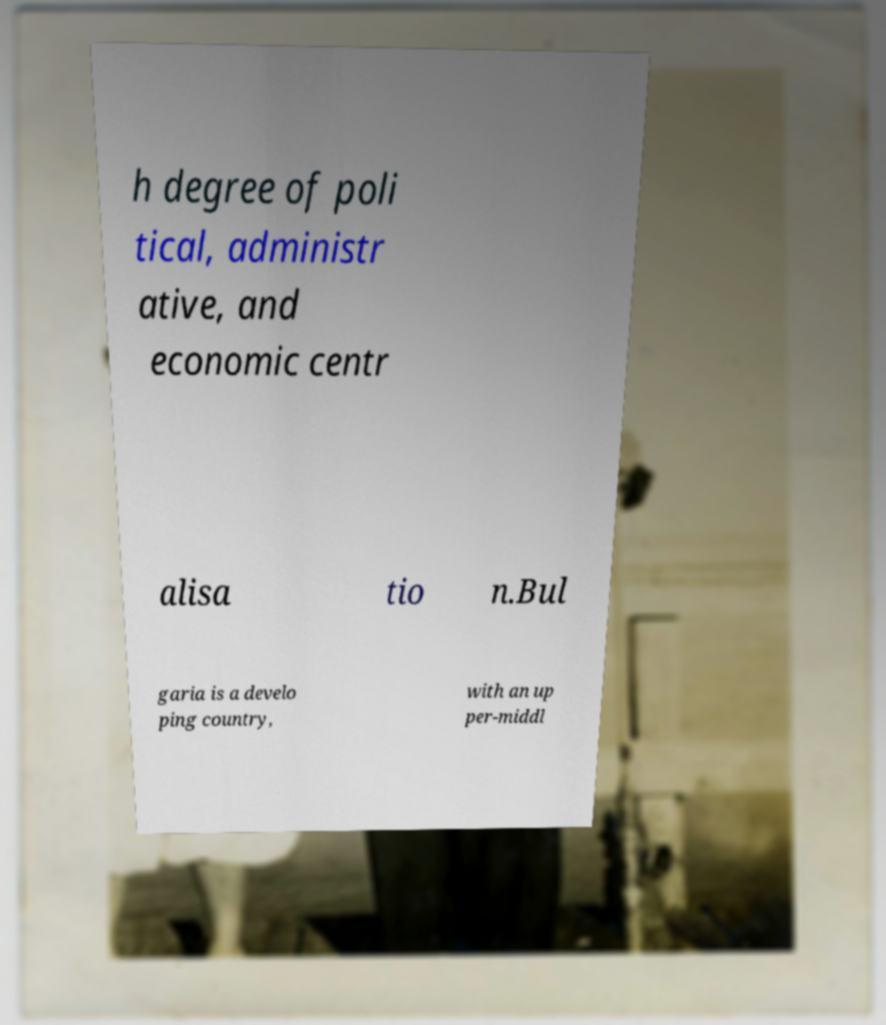Can you read and provide the text displayed in the image?This photo seems to have some interesting text. Can you extract and type it out for me? h degree of poli tical, administr ative, and economic centr alisa tio n.Bul garia is a develo ping country, with an up per-middl 